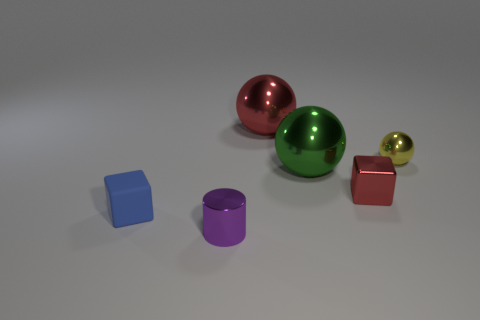Which object is the smallest, and what is its color? The smallest object in the image is the gold sphere. 